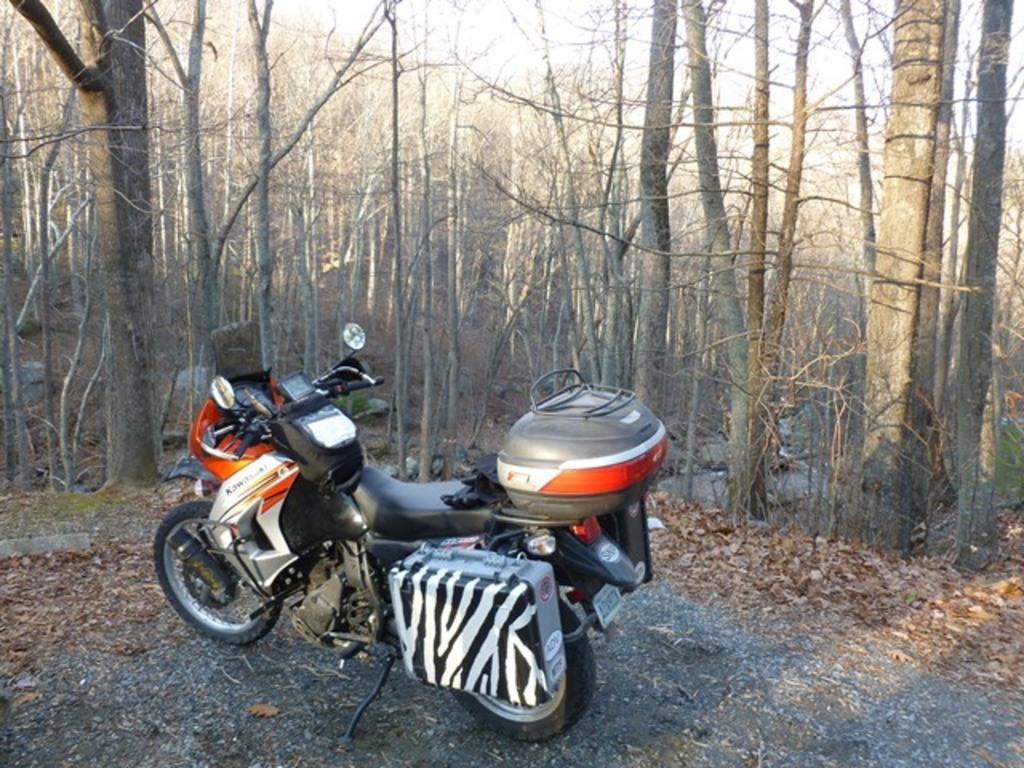What type of vehicle is on the ground in the image? There is a motorcycle on the ground in the image. What natural elements can be seen on the ground in the image? Dried leaves and stones are visible in the image. What can be seen in the background of the image? There are trees and the sky visible in the background of the image. How many clocks are hanging on the trees in the image? There are no clocks hanging on the trees in the image. What type of paste is being used to stick the stones together in the image? There is no paste or any indication of stones being stuck together in the image. 